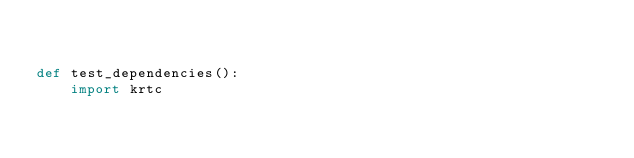<code> <loc_0><loc_0><loc_500><loc_500><_Python_>

def test_dependencies():
    import krtc
</code> 